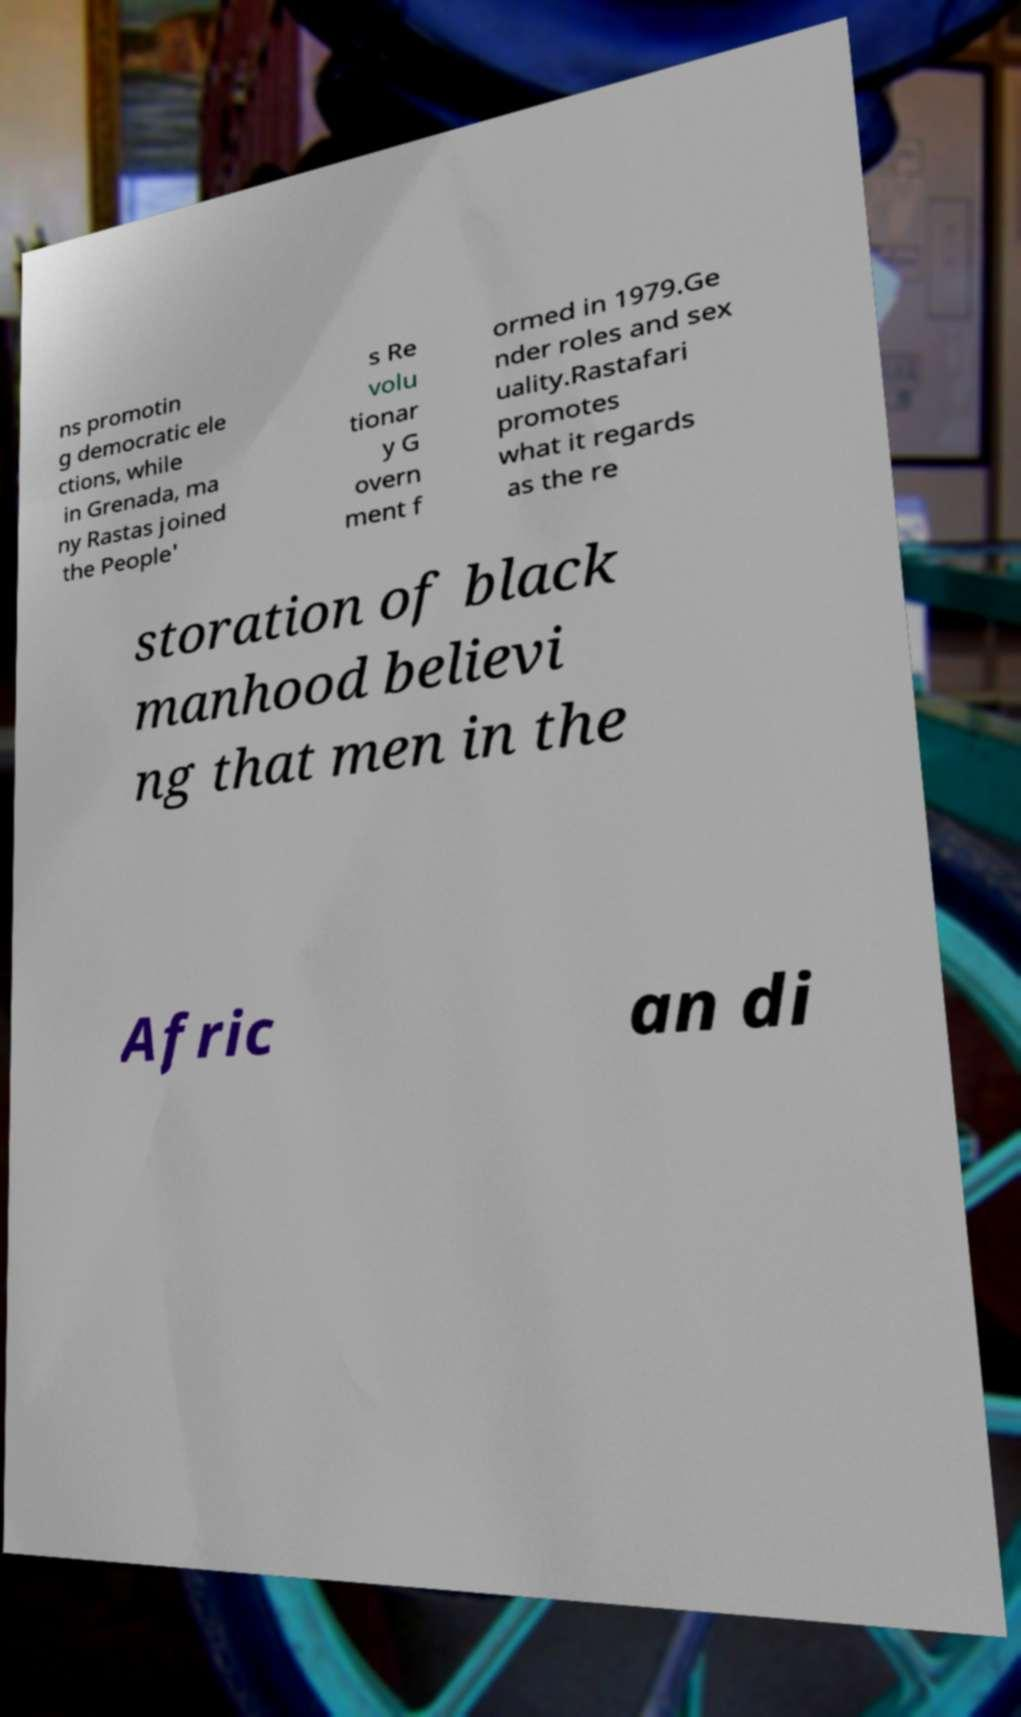There's text embedded in this image that I need extracted. Can you transcribe it verbatim? ns promotin g democratic ele ctions, while in Grenada, ma ny Rastas joined the People' s Re volu tionar y G overn ment f ormed in 1979.Ge nder roles and sex uality.Rastafari promotes what it regards as the re storation of black manhood believi ng that men in the Afric an di 